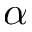<formula> <loc_0><loc_0><loc_500><loc_500>\alpha</formula> 